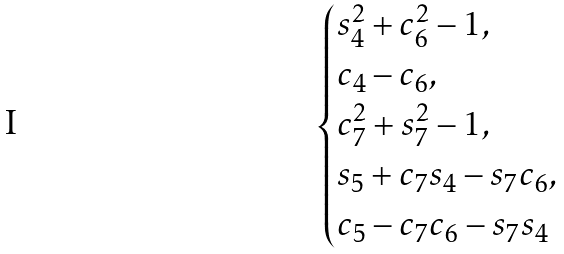<formula> <loc_0><loc_0><loc_500><loc_500>\begin{cases} s _ { 4 } ^ { 2 } + c _ { 6 } ^ { 2 } - 1 , \\ c _ { 4 } - c _ { 6 } , \\ c _ { 7 } ^ { 2 } + s _ { 7 } ^ { 2 } - 1 , \\ s _ { 5 } + c _ { 7 } s _ { 4 } - s _ { 7 } c _ { 6 } , \\ c _ { 5 } - c _ { 7 } c _ { 6 } - s _ { 7 } s _ { 4 } \end{cases}</formula> 